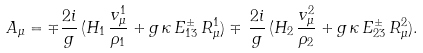<formula> <loc_0><loc_0><loc_500><loc_500>A _ { \mu } = \mp { \frac { 2 i } { g } } \, ( H _ { 1 } \, { \frac { v _ { \mu } ^ { 1 } } { \rho _ { 1 } } } + g \, \kappa \, E _ { 1 3 } ^ { \pm } \, R _ { \mu } ^ { 1 } ) \mp \, { \frac { 2 i } { g } } \, ( H _ { 2 } \, { \frac { v _ { \mu } ^ { 2 } } { \rho _ { 2 } } } + g \, \kappa \, E _ { 2 3 } ^ { \pm } \, R _ { \mu } ^ { 2 } ) .</formula> 